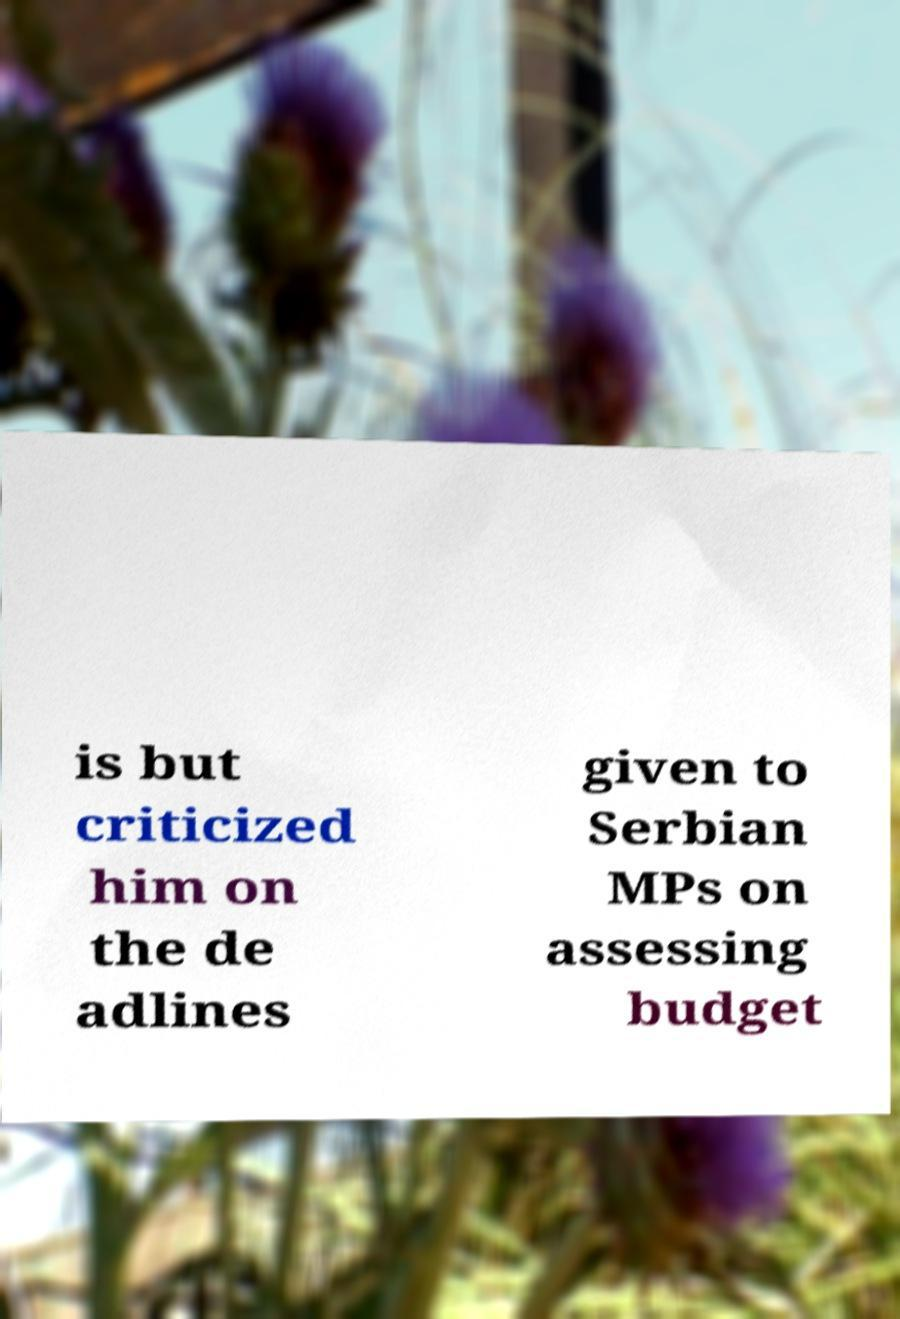Could you extract and type out the text from this image? is but criticized him on the de adlines given to Serbian MPs on assessing budget 